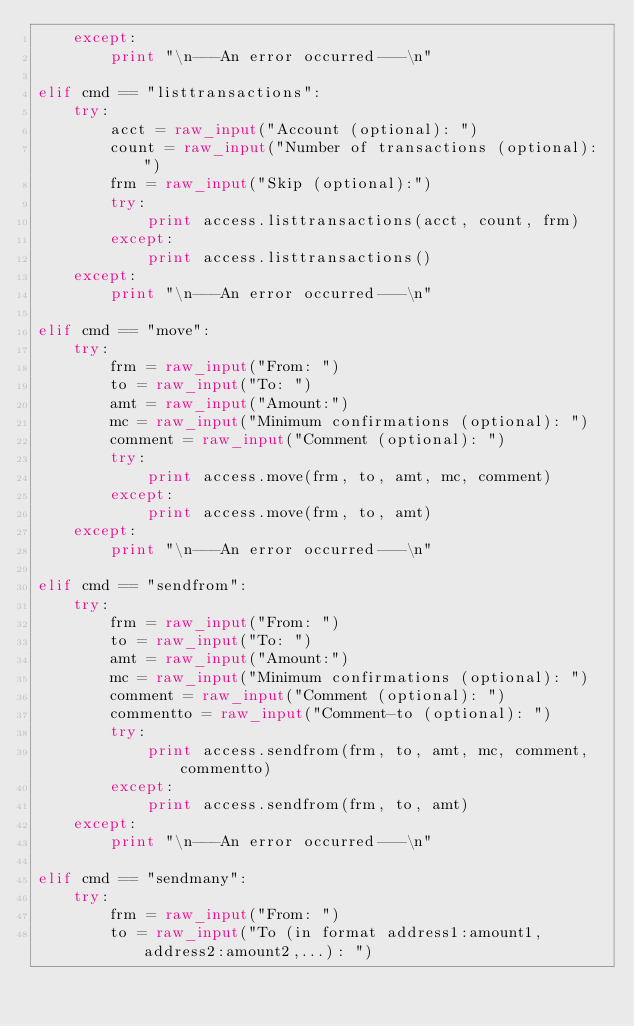Convert code to text. <code><loc_0><loc_0><loc_500><loc_500><_Python_>    except:
        print "\n---An error occurred---\n"

elif cmd == "listtransactions":
    try:
        acct = raw_input("Account (optional): ")
        count = raw_input("Number of transactions (optional): ")
        frm = raw_input("Skip (optional):")
        try:
            print access.listtransactions(acct, count, frm)
        except:
            print access.listtransactions()
    except:
        print "\n---An error occurred---\n"

elif cmd == "move":
    try:
        frm = raw_input("From: ")
        to = raw_input("To: ")
        amt = raw_input("Amount:")
        mc = raw_input("Minimum confirmations (optional): ")
        comment = raw_input("Comment (optional): ")
        try:
            print access.move(frm, to, amt, mc, comment)
        except:
            print access.move(frm, to, amt)
    except:
        print "\n---An error occurred---\n"

elif cmd == "sendfrom":
    try:
        frm = raw_input("From: ")
        to = raw_input("To: ")
        amt = raw_input("Amount:")
        mc = raw_input("Minimum confirmations (optional): ")
        comment = raw_input("Comment (optional): ")
        commentto = raw_input("Comment-to (optional): ")
        try:
            print access.sendfrom(frm, to, amt, mc, comment, commentto)
        except:
            print access.sendfrom(frm, to, amt)
    except:
        print "\n---An error occurred---\n"

elif cmd == "sendmany":
    try:
        frm = raw_input("From: ")
        to = raw_input("To (in format address1:amount1,address2:amount2,...): ")</code> 